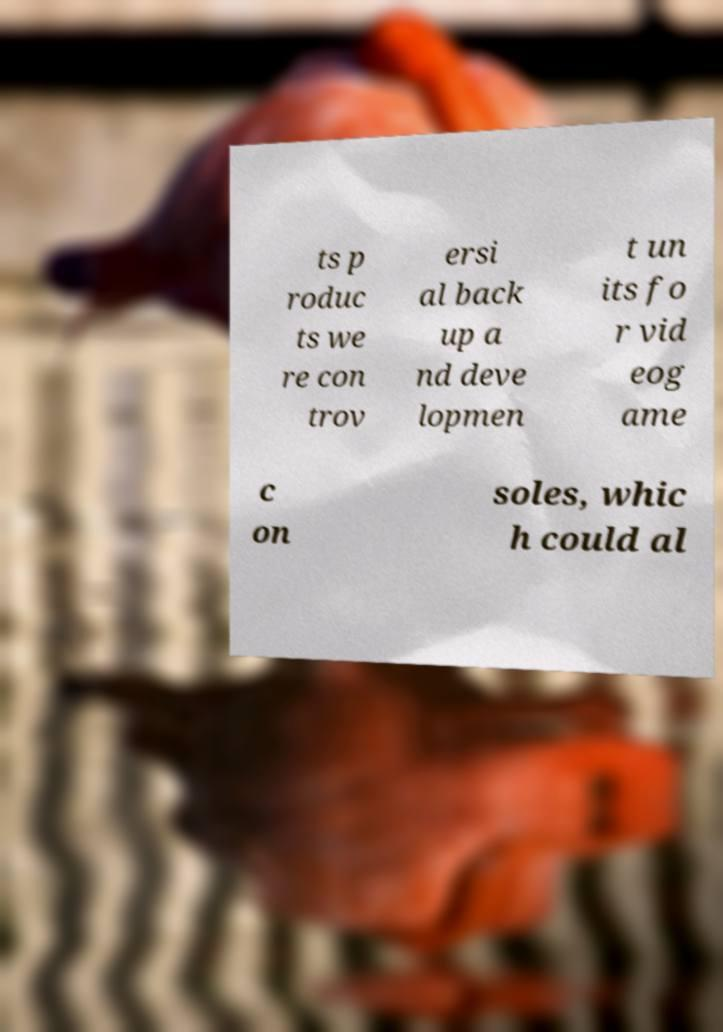Please read and relay the text visible in this image. What does it say? ts p roduc ts we re con trov ersi al back up a nd deve lopmen t un its fo r vid eog ame c on soles, whic h could al 